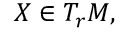Convert formula to latex. <formula><loc_0><loc_0><loc_500><loc_500>X \in T _ { r } M ,</formula> 